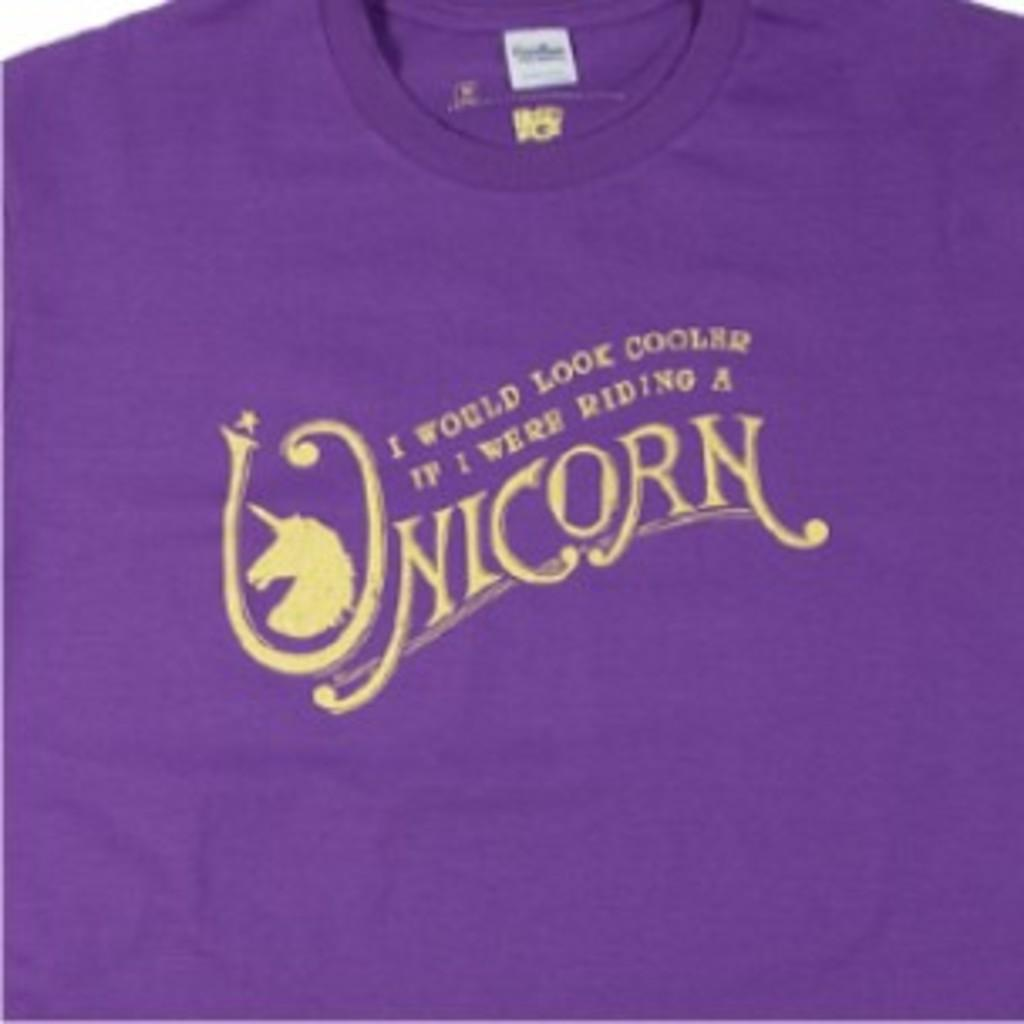What color is the t-shirt in the image? The t-shirt in the image is purple. What is written on the t-shirt? The word "unicorn" is written on the t-shirt. What type of breakfast is being served on the hat in the image? There is no hat or breakfast present in the image; it only features a purple t-shirt with the word "unicorn" written on it. 